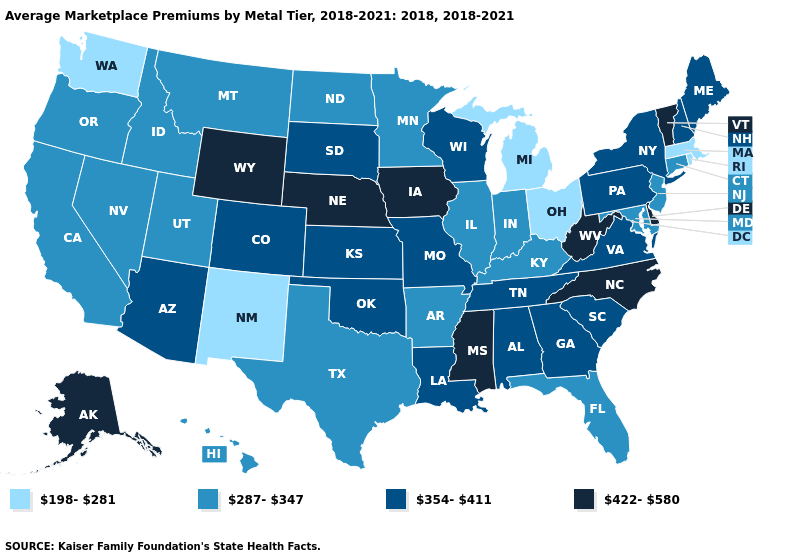Does Michigan have the lowest value in the USA?
Write a very short answer. Yes. Does Ohio have the lowest value in the MidWest?
Concise answer only. Yes. Name the states that have a value in the range 354-411?
Concise answer only. Alabama, Arizona, Colorado, Georgia, Kansas, Louisiana, Maine, Missouri, New Hampshire, New York, Oklahoma, Pennsylvania, South Carolina, South Dakota, Tennessee, Virginia, Wisconsin. How many symbols are there in the legend?
Keep it brief. 4. What is the value of Vermont?
Quick response, please. 422-580. Is the legend a continuous bar?
Be succinct. No. What is the highest value in the South ?
Keep it brief. 422-580. What is the value of New Jersey?
Write a very short answer. 287-347. What is the value of Virginia?
Give a very brief answer. 354-411. Does Arkansas have the lowest value in the South?
Concise answer only. Yes. Which states have the highest value in the USA?
Quick response, please. Alaska, Delaware, Iowa, Mississippi, Nebraska, North Carolina, Vermont, West Virginia, Wyoming. What is the lowest value in states that border New York?
Answer briefly. 198-281. What is the lowest value in states that border Oklahoma?
Be succinct. 198-281. What is the value of Nevada?
Write a very short answer. 287-347. Does North Dakota have the lowest value in the USA?
Be succinct. No. 